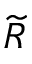Convert formula to latex. <formula><loc_0><loc_0><loc_500><loc_500>\widetilde { R }</formula> 